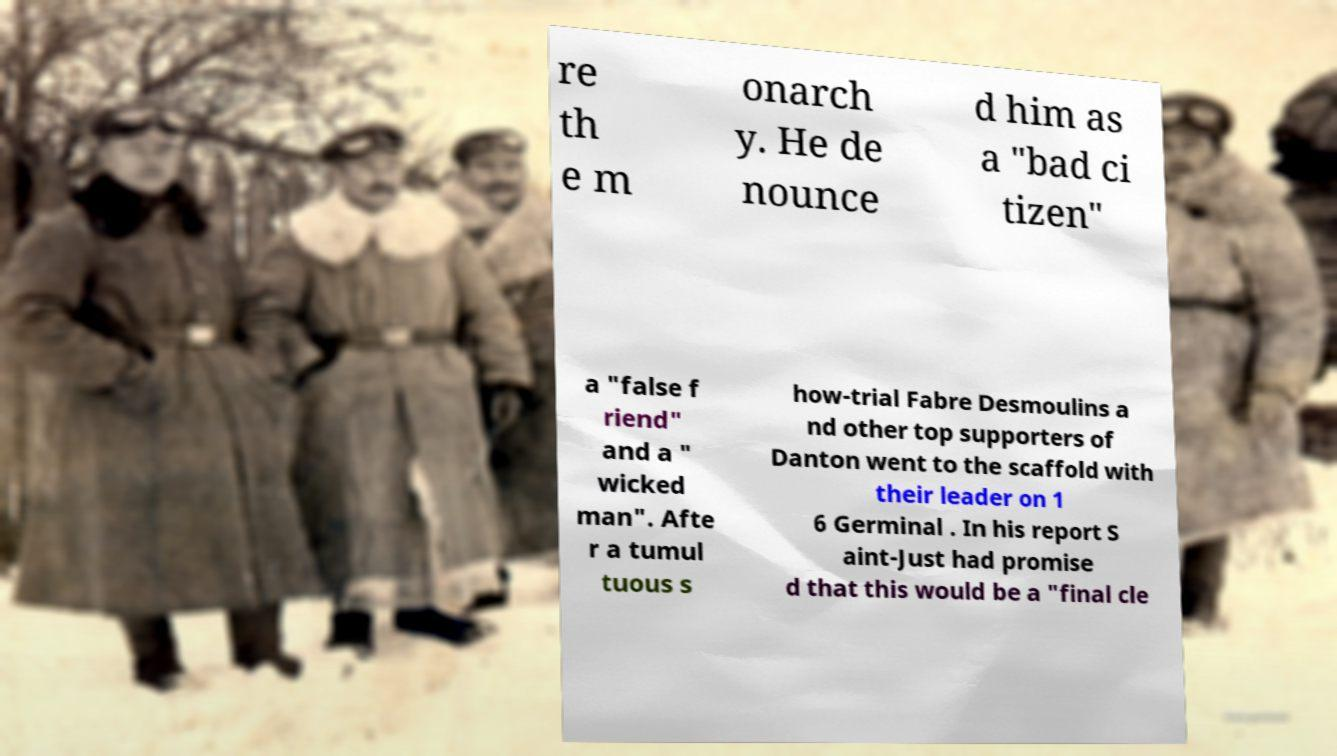What messages or text are displayed in this image? I need them in a readable, typed format. re th e m onarch y. He de nounce d him as a "bad ci tizen" a "false f riend" and a " wicked man". Afte r a tumul tuous s how-trial Fabre Desmoulins a nd other top supporters of Danton went to the scaffold with their leader on 1 6 Germinal . In his report S aint-Just had promise d that this would be a "final cle 